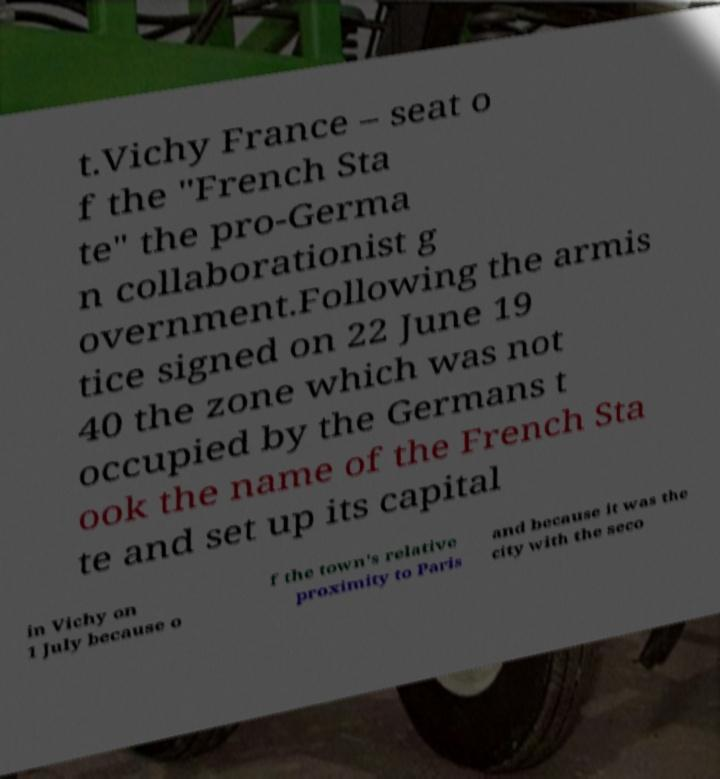Please read and relay the text visible in this image. What does it say? t.Vichy France – seat o f the "French Sta te" the pro-Germa n collaborationist g overnment.Following the armis tice signed on 22 June 19 40 the zone which was not occupied by the Germans t ook the name of the French Sta te and set up its capital in Vichy on 1 July because o f the town's relative proximity to Paris and because it was the city with the seco 